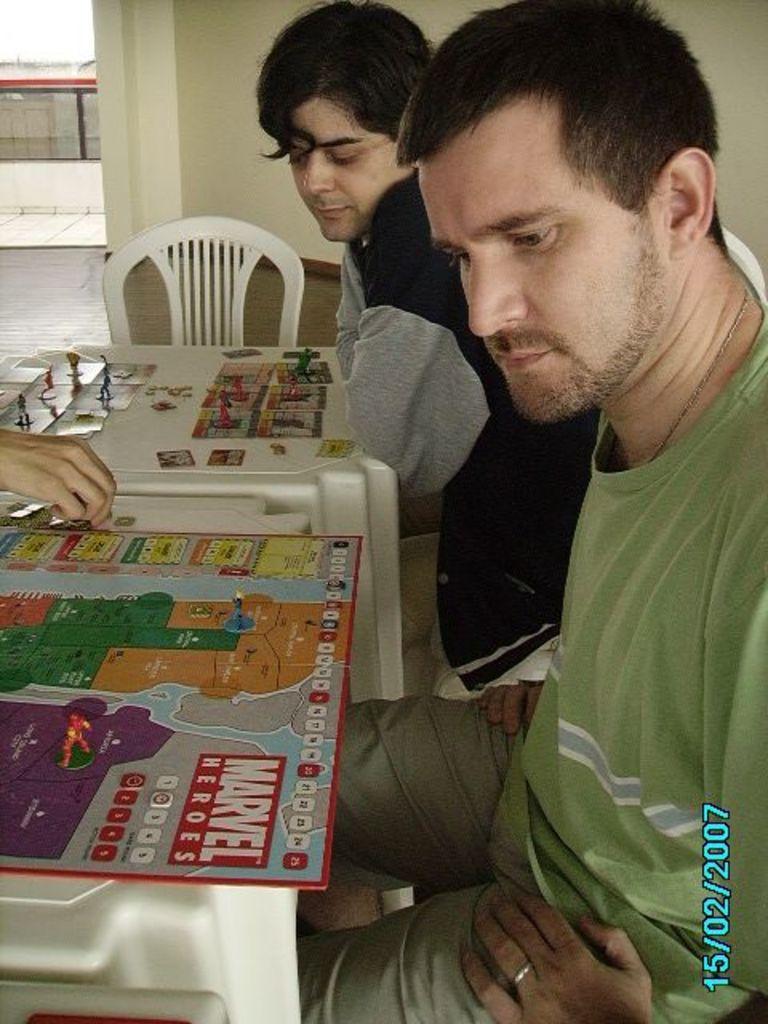How would you summarize this image in a sentence or two? As we can see in the image there are two persons sitting on chair. In front of the person there is a table and a board here. Behind them there is a wall. 